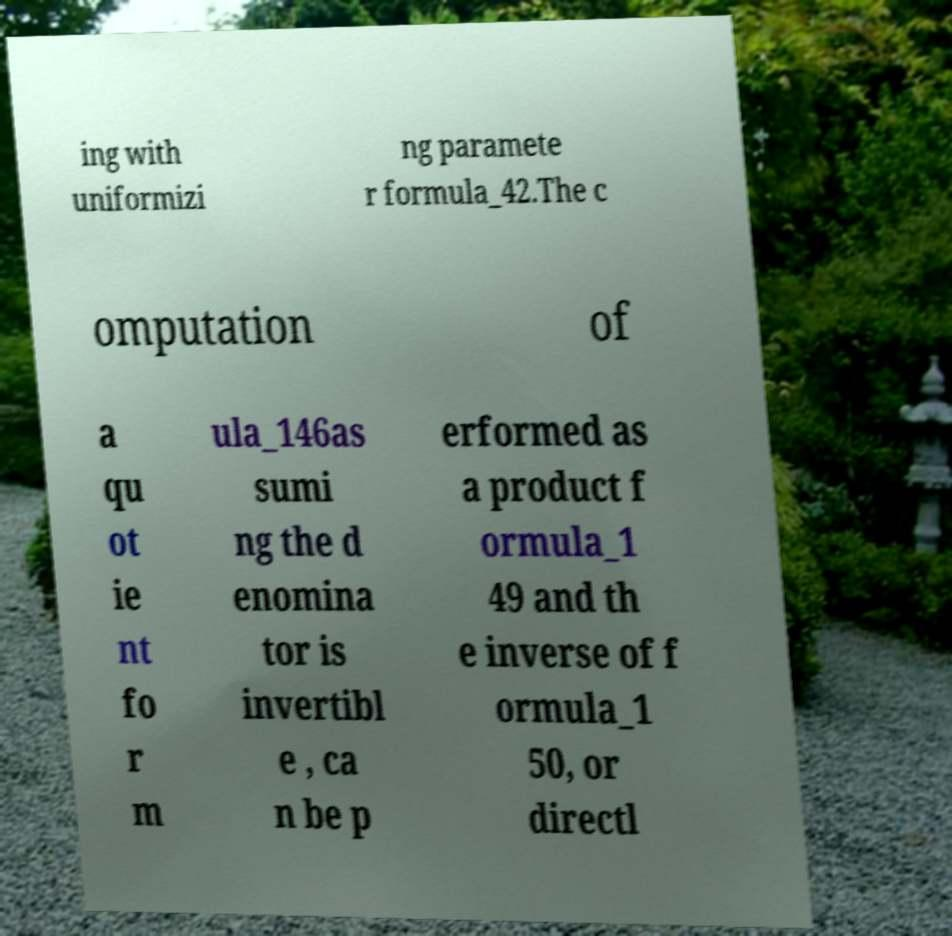I need the written content from this picture converted into text. Can you do that? ing with uniformizi ng paramete r formula_42.The c omputation of a qu ot ie nt fo r m ula_146as sumi ng the d enomina tor is invertibl e , ca n be p erformed as a product f ormula_1 49 and th e inverse of f ormula_1 50, or directl 